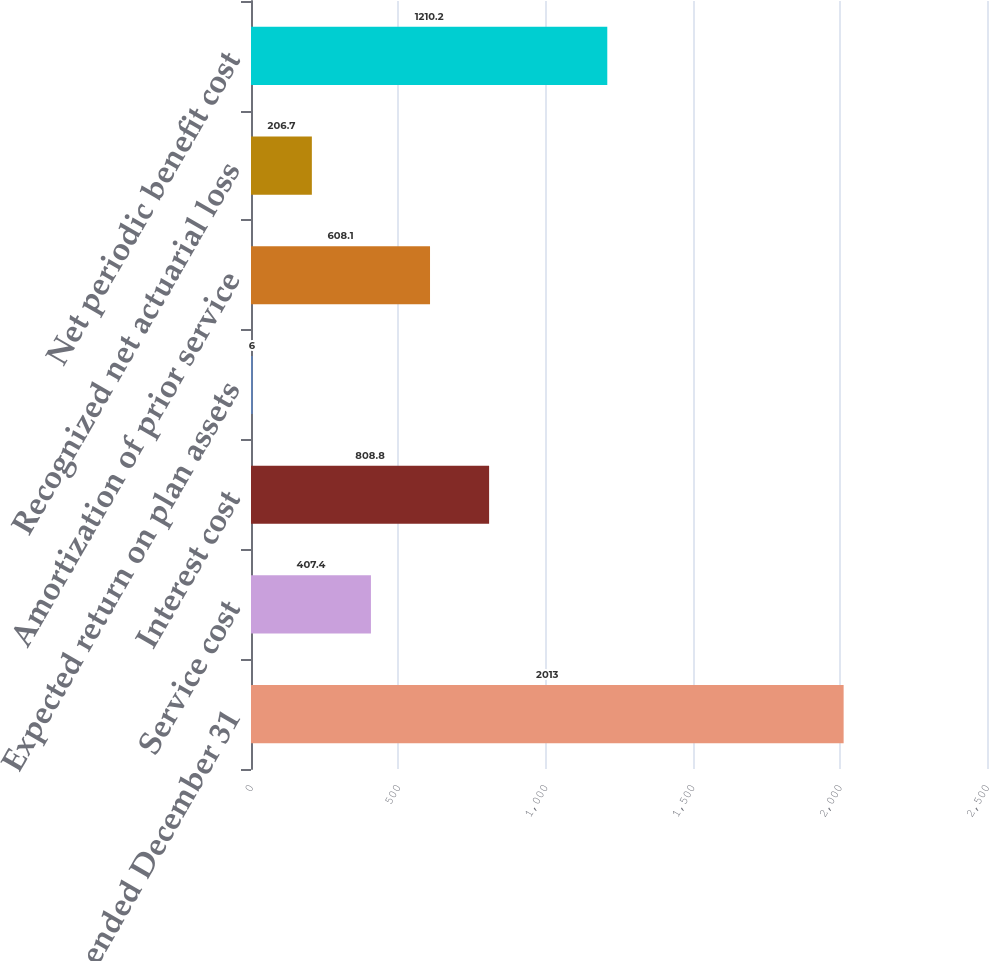Convert chart to OTSL. <chart><loc_0><loc_0><loc_500><loc_500><bar_chart><fcel>Years ended December 31<fcel>Service cost<fcel>Interest cost<fcel>Expected return on plan assets<fcel>Amortization of prior service<fcel>Recognized net actuarial loss<fcel>Net periodic benefit cost<nl><fcel>2013<fcel>407.4<fcel>808.8<fcel>6<fcel>608.1<fcel>206.7<fcel>1210.2<nl></chart> 